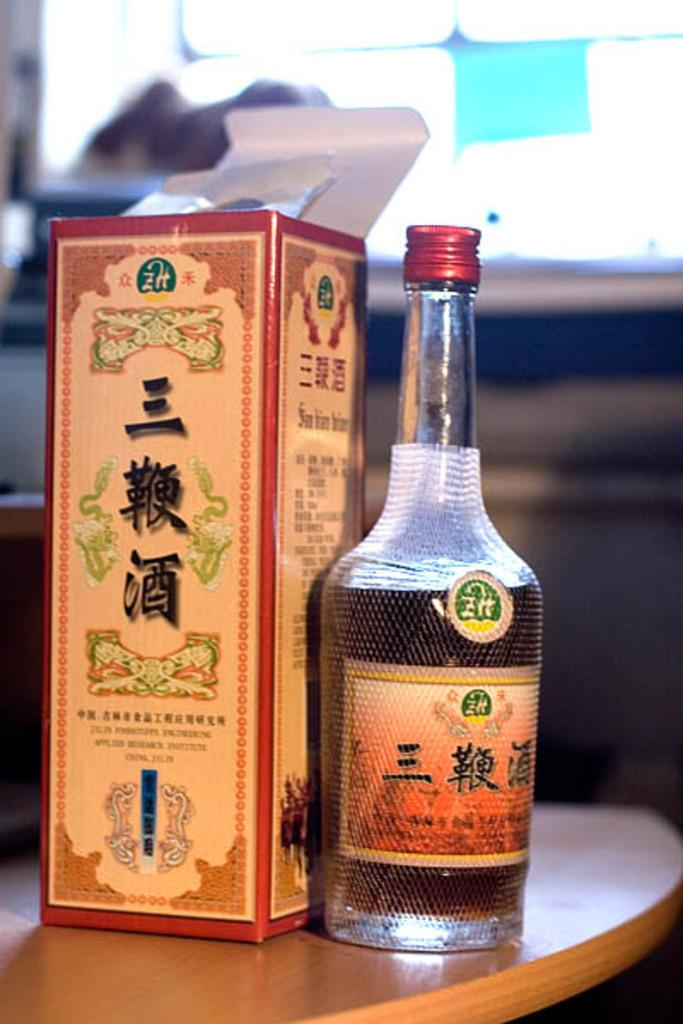Provide a one-sentence caption for the provided image. Lots of foreign words are written on thsi bottle and box. 